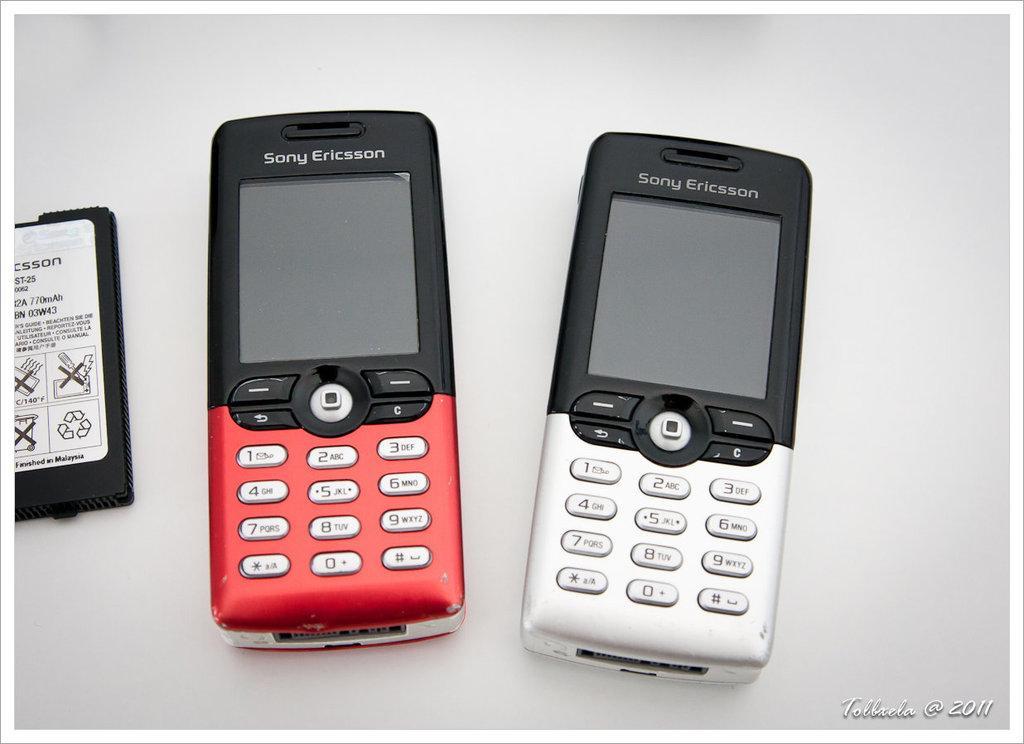Please provide a concise description of this image. In the picture we can see a battery and two mobile phones are placed beside it. 